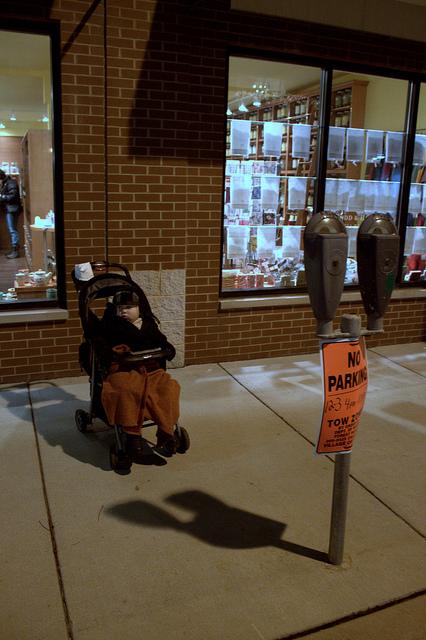Does one of the people know how to read?
Be succinct. No. What is the child sitting on?
Be succinct. Stroller. Is he playing a wifi game?
Concise answer only. No. Is the person sitting on the sidewalk a male or female?
Quick response, please. Male. Is the person sitting in a wheelchair?
Write a very short answer. No. Where is the little girl?
Answer briefly. Sidewalk. What is the boy sitting on?
Quick response, please. Stroller. How much to park there?
Answer briefly. No parking. 